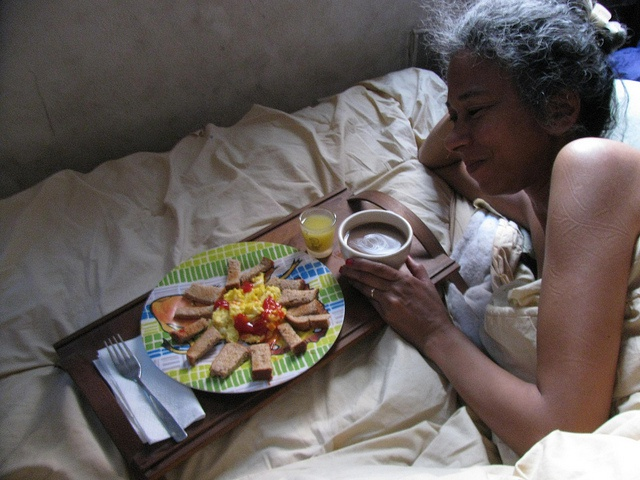Describe the objects in this image and their specific colors. I can see bed in black, gray, darkgray, and lightgray tones, people in black, gray, maroon, and brown tones, cup in black, gray, lavender, and darkgray tones, bowl in black, gray, lavender, and darkgray tones, and fork in black, gray, and darkblue tones in this image. 